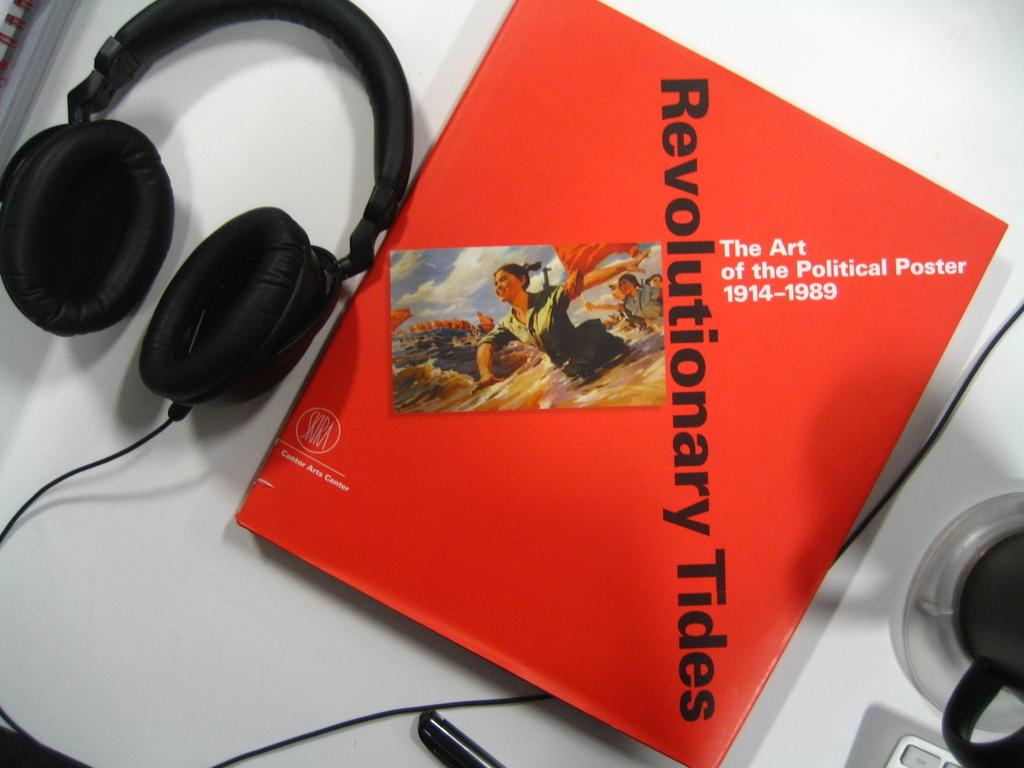What type of headset is in the image? There is a black color headset in the image. What other items can be seen in the image besides the headset? There is a book, a pen, and a cup in the image. What color is the cup in the image? The cup is black in color. Where are all the items placed in the image? All items are placed on a table. Can you tell me how many libraries are visible in the image? There are no libraries present in the image; it only shows a headset, a book, a pen, a cup, and a table. What type of gardening tool is used by the person in the image? There is no person or gardening tool present in the image. 